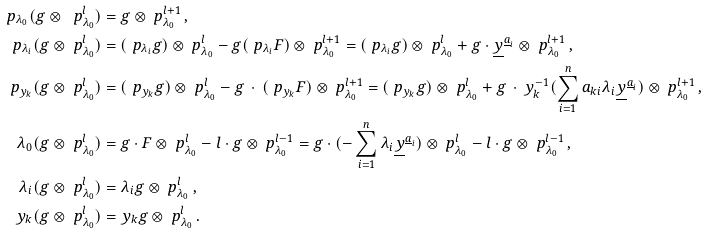<formula> <loc_0><loc_0><loc_500><loc_500>\ p _ { \lambda _ { 0 } } ( g \otimes \ p _ { \lambda _ { 0 } } ^ { l } ) & = g \otimes \ p _ { \lambda _ { 0 } } ^ { l + 1 } \, , \\ \ p _ { \lambda _ { i } } ( g \otimes \ p _ { \lambda _ { 0 } } ^ { l } ) & = ( \ p _ { \lambda _ { i } } g ) \otimes \ p _ { \lambda _ { 0 } } ^ { l } - g ( \ p _ { \lambda _ { i } } F ) \otimes \ p _ { \lambda _ { 0 } } ^ { l + 1 } = ( \ p _ { \lambda _ { i } } g ) \otimes \ p _ { \lambda _ { 0 } } ^ { l } + g \cdot \underline { y } ^ { \underline { a } _ { i } } \otimes \ p _ { \lambda _ { 0 } } ^ { l + 1 } \, , \\ \ p _ { y _ { k } } ( g \otimes \ p _ { \lambda _ { 0 } } ^ { l } ) & = ( \ p _ { y _ { k } } g ) \otimes \ p _ { \lambda _ { 0 } } ^ { l } - g \, \cdot \, ( \ p _ { y _ { k } } F ) \otimes \ p _ { \lambda _ { 0 } } ^ { l + 1 } = ( \ p _ { y _ { k } } g ) \otimes \ p _ { \lambda _ { 0 } } ^ { l } + g \, \cdot \, y _ { k } ^ { - 1 } ( \sum _ { i = 1 } ^ { n } a _ { k i } \lambda _ { i } \underline { y } ^ { \underline { a } _ { i } } ) \otimes \ p _ { \lambda _ { 0 } } ^ { l + 1 } \, , \\ \lambda _ { 0 } ( g \otimes \ p _ { \lambda _ { 0 } } ^ { l } ) & = g \cdot F \otimes \ p _ { \lambda _ { 0 } } ^ { l } - l \cdot g \otimes \ p _ { \lambda _ { 0 } } ^ { l - 1 } = g \cdot ( - \sum _ { i = 1 } ^ { n } \lambda _ { i } \underline { y } ^ { \underline { a } _ { i } } ) \otimes \ p _ { \lambda _ { 0 } } ^ { l } - l \cdot g \otimes \ p _ { \lambda _ { 0 } } ^ { l - 1 } \, , \\ \lambda _ { i } ( g \otimes \ p _ { \lambda _ { 0 } } ^ { l } ) & = \lambda _ { i } g \otimes \ p _ { \lambda _ { 0 } } ^ { l } \, , \\ y _ { k } ( g \otimes \ p _ { \lambda _ { 0 } } ^ { l } ) & = y _ { k } g \otimes \ p _ { \lambda _ { 0 } } ^ { l } \, .</formula> 